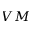Convert formula to latex. <formula><loc_0><loc_0><loc_500><loc_500>V M</formula> 